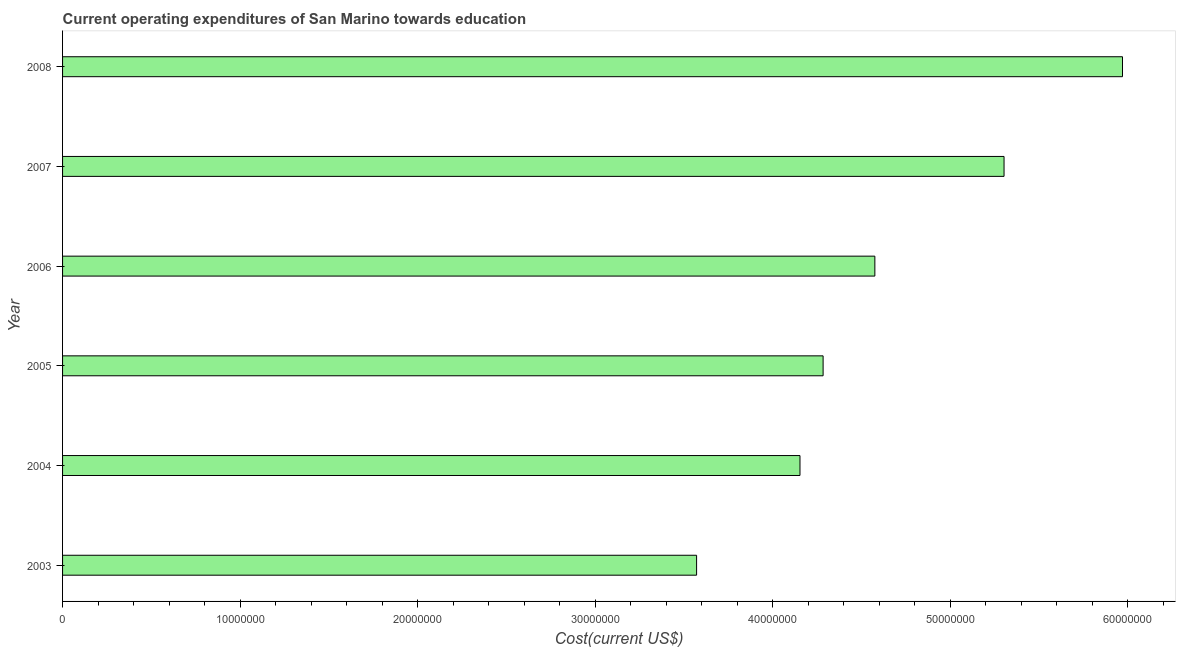Does the graph contain grids?
Ensure brevity in your answer.  No. What is the title of the graph?
Your answer should be very brief. Current operating expenditures of San Marino towards education. What is the label or title of the X-axis?
Your response must be concise. Cost(current US$). What is the education expenditure in 2005?
Ensure brevity in your answer.  4.28e+07. Across all years, what is the maximum education expenditure?
Make the answer very short. 5.97e+07. Across all years, what is the minimum education expenditure?
Your answer should be very brief. 3.57e+07. In which year was the education expenditure maximum?
Your response must be concise. 2008. In which year was the education expenditure minimum?
Your response must be concise. 2003. What is the sum of the education expenditure?
Your answer should be very brief. 2.79e+08. What is the difference between the education expenditure in 2004 and 2008?
Your answer should be very brief. -1.82e+07. What is the average education expenditure per year?
Keep it short and to the point. 4.64e+07. What is the median education expenditure?
Provide a succinct answer. 4.43e+07. In how many years, is the education expenditure greater than 36000000 US$?
Ensure brevity in your answer.  5. Do a majority of the years between 2003 and 2008 (inclusive) have education expenditure greater than 58000000 US$?
Your response must be concise. No. What is the ratio of the education expenditure in 2003 to that in 2008?
Give a very brief answer. 0.6. Is the education expenditure in 2005 less than that in 2006?
Provide a short and direct response. Yes. What is the difference between the highest and the second highest education expenditure?
Your answer should be compact. 6.67e+06. Is the sum of the education expenditure in 2003 and 2008 greater than the maximum education expenditure across all years?
Ensure brevity in your answer.  Yes. What is the difference between the highest and the lowest education expenditure?
Provide a short and direct response. 2.40e+07. Are all the bars in the graph horizontal?
Your answer should be compact. Yes. What is the difference between two consecutive major ticks on the X-axis?
Your response must be concise. 1.00e+07. Are the values on the major ticks of X-axis written in scientific E-notation?
Your response must be concise. No. What is the Cost(current US$) of 2003?
Offer a very short reply. 3.57e+07. What is the Cost(current US$) in 2004?
Provide a succinct answer. 4.15e+07. What is the Cost(current US$) in 2005?
Provide a succinct answer. 4.28e+07. What is the Cost(current US$) in 2006?
Make the answer very short. 4.57e+07. What is the Cost(current US$) in 2007?
Make the answer very short. 5.30e+07. What is the Cost(current US$) of 2008?
Provide a short and direct response. 5.97e+07. What is the difference between the Cost(current US$) in 2003 and 2004?
Offer a terse response. -5.82e+06. What is the difference between the Cost(current US$) in 2003 and 2005?
Your answer should be very brief. -7.13e+06. What is the difference between the Cost(current US$) in 2003 and 2006?
Keep it short and to the point. -1.00e+07. What is the difference between the Cost(current US$) in 2003 and 2007?
Your response must be concise. -1.73e+07. What is the difference between the Cost(current US$) in 2003 and 2008?
Provide a succinct answer. -2.40e+07. What is the difference between the Cost(current US$) in 2004 and 2005?
Your answer should be compact. -1.30e+06. What is the difference between the Cost(current US$) in 2004 and 2006?
Provide a succinct answer. -4.22e+06. What is the difference between the Cost(current US$) in 2004 and 2007?
Offer a very short reply. -1.15e+07. What is the difference between the Cost(current US$) in 2004 and 2008?
Your answer should be compact. -1.82e+07. What is the difference between the Cost(current US$) in 2005 and 2006?
Offer a terse response. -2.91e+06. What is the difference between the Cost(current US$) in 2005 and 2007?
Your answer should be compact. -1.02e+07. What is the difference between the Cost(current US$) in 2005 and 2008?
Keep it short and to the point. -1.69e+07. What is the difference between the Cost(current US$) in 2006 and 2007?
Keep it short and to the point. -7.28e+06. What is the difference between the Cost(current US$) in 2006 and 2008?
Offer a terse response. -1.39e+07. What is the difference between the Cost(current US$) in 2007 and 2008?
Your response must be concise. -6.67e+06. What is the ratio of the Cost(current US$) in 2003 to that in 2004?
Your answer should be very brief. 0.86. What is the ratio of the Cost(current US$) in 2003 to that in 2005?
Your response must be concise. 0.83. What is the ratio of the Cost(current US$) in 2003 to that in 2006?
Your response must be concise. 0.78. What is the ratio of the Cost(current US$) in 2003 to that in 2007?
Your answer should be compact. 0.67. What is the ratio of the Cost(current US$) in 2003 to that in 2008?
Ensure brevity in your answer.  0.6. What is the ratio of the Cost(current US$) in 2004 to that in 2005?
Your answer should be very brief. 0.97. What is the ratio of the Cost(current US$) in 2004 to that in 2006?
Keep it short and to the point. 0.91. What is the ratio of the Cost(current US$) in 2004 to that in 2007?
Keep it short and to the point. 0.78. What is the ratio of the Cost(current US$) in 2004 to that in 2008?
Keep it short and to the point. 0.7. What is the ratio of the Cost(current US$) in 2005 to that in 2006?
Your answer should be compact. 0.94. What is the ratio of the Cost(current US$) in 2005 to that in 2007?
Your answer should be very brief. 0.81. What is the ratio of the Cost(current US$) in 2005 to that in 2008?
Ensure brevity in your answer.  0.72. What is the ratio of the Cost(current US$) in 2006 to that in 2007?
Provide a short and direct response. 0.86. What is the ratio of the Cost(current US$) in 2006 to that in 2008?
Provide a succinct answer. 0.77. What is the ratio of the Cost(current US$) in 2007 to that in 2008?
Your answer should be compact. 0.89. 